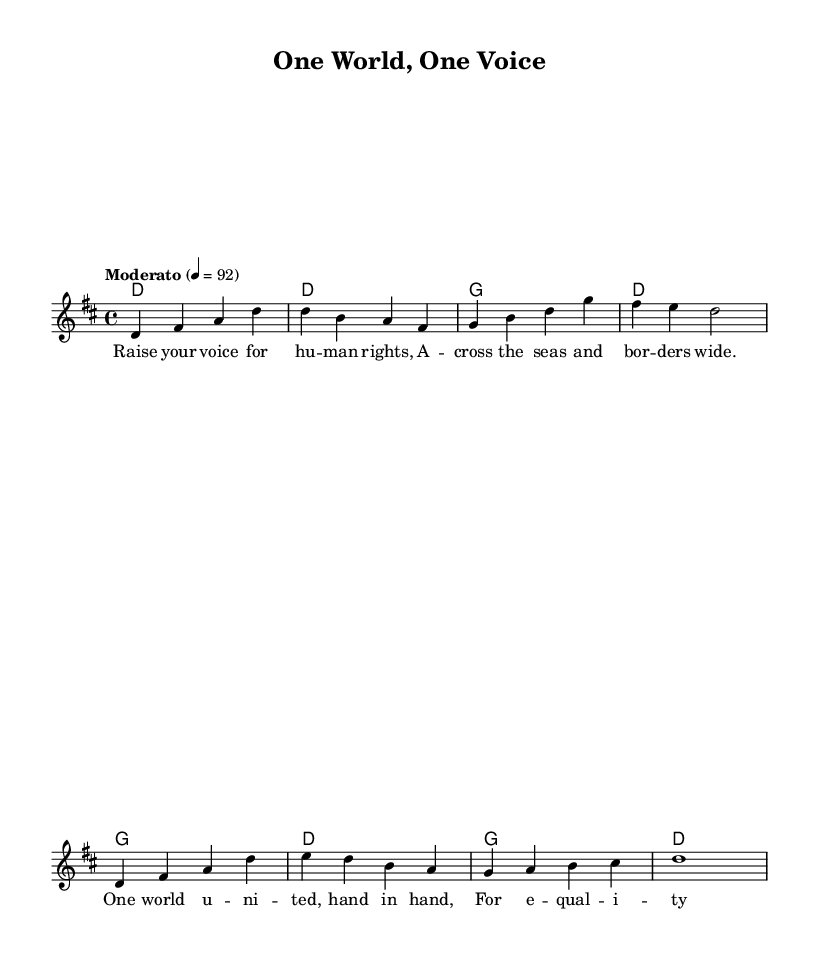What is the key signature of this music? The key signature is D major, which has two sharps: F# and C#.
Answer: D major What is the time signature of this music? The time signature is 4/4, indicating four beats per measure.
Answer: 4/4 What is the tempo of this piece? The tempo marking is "Moderato," indicating a moderately slow speed of 92 beats per minute.
Answer: Moderato How many distinct chords are used in the harmonies section? There are three distinct chords used: D, G, and a variation of D. Each appears in a cyclic manner.
Answer: Three What is the main theme of the lyrics in this song? The lyrics emphasize unity and advocacy for human rights and equality across borders.
Answer: Unity and advocacy for human rights What is the structure of the song? The song is structured with a melody, accompanying chords, and a verse consisting of lyrics aligned with the melody.
Answer: Melody, chords, and verse What is the main message conveyed through the lyrics? The lyrics convey a message of togetherness and standing for equality and human rights.
Answer: Togetherness and standing for equality 